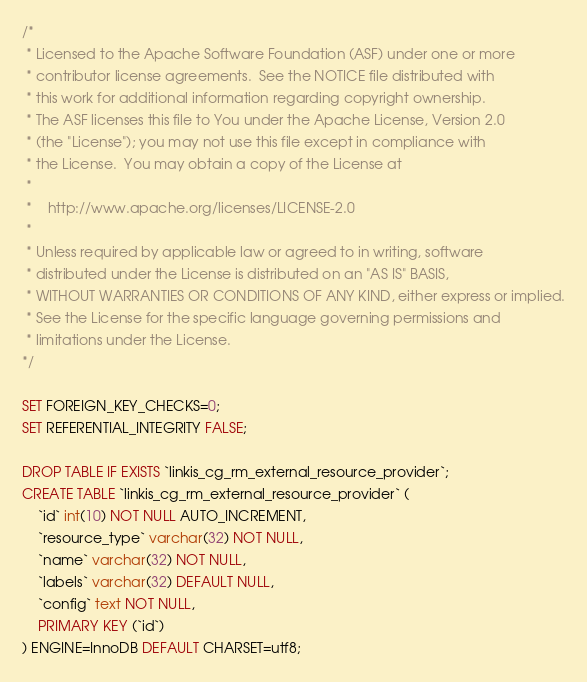<code> <loc_0><loc_0><loc_500><loc_500><_SQL_>/*
 * Licensed to the Apache Software Foundation (ASF) under one or more
 * contributor license agreements.  See the NOTICE file distributed with
 * this work for additional information regarding copyright ownership.
 * The ASF licenses this file to You under the Apache License, Version 2.0
 * (the "License"); you may not use this file except in compliance with
 * the License.  You may obtain a copy of the License at
 *
 *    http://www.apache.org/licenses/LICENSE-2.0
 *
 * Unless required by applicable law or agreed to in writing, software
 * distributed under the License is distributed on an "AS IS" BASIS,
 * WITHOUT WARRANTIES OR CONDITIONS OF ANY KIND, either express or implied.
 * See the License for the specific language governing permissions and
 * limitations under the License.
*/

SET FOREIGN_KEY_CHECKS=0;
SET REFERENTIAL_INTEGRITY FALSE;

DROP TABLE IF EXISTS `linkis_cg_rm_external_resource_provider`;
CREATE TABLE `linkis_cg_rm_external_resource_provider` (
    `id` int(10) NOT NULL AUTO_INCREMENT,
    `resource_type` varchar(32) NOT NULL,
    `name` varchar(32) NOT NULL,
    `labels` varchar(32) DEFAULT NULL,
    `config` text NOT NULL,
    PRIMARY KEY (`id`)
) ENGINE=InnoDB DEFAULT CHARSET=utf8;</code> 